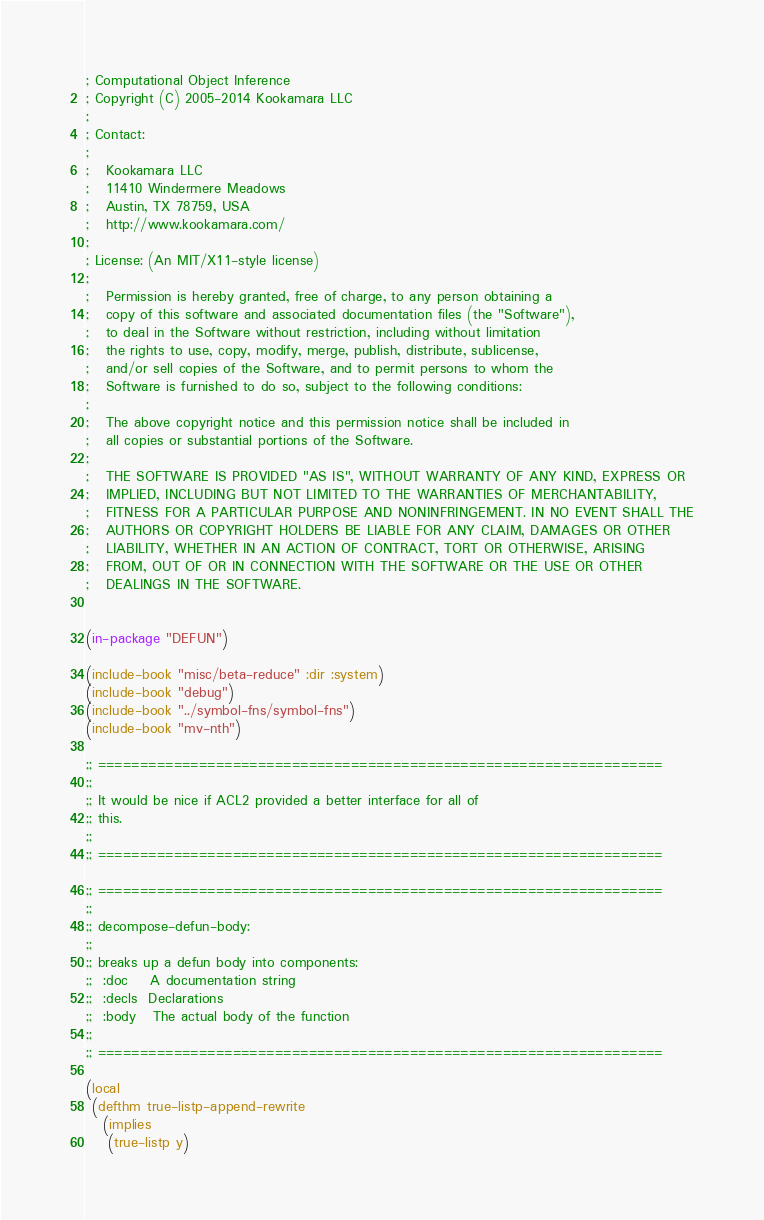Convert code to text. <code><loc_0><loc_0><loc_500><loc_500><_Lisp_>; Computational Object Inference
; Copyright (C) 2005-2014 Kookamara LLC
;
; Contact:
;
;   Kookamara LLC
;   11410 Windermere Meadows
;   Austin, TX 78759, USA
;   http://www.kookamara.com/
;
; License: (An MIT/X11-style license)
;
;   Permission is hereby granted, free of charge, to any person obtaining a
;   copy of this software and associated documentation files (the "Software"),
;   to deal in the Software without restriction, including without limitation
;   the rights to use, copy, modify, merge, publish, distribute, sublicense,
;   and/or sell copies of the Software, and to permit persons to whom the
;   Software is furnished to do so, subject to the following conditions:
;
;   The above copyright notice and this permission notice shall be included in
;   all copies or substantial portions of the Software.
;
;   THE SOFTWARE IS PROVIDED "AS IS", WITHOUT WARRANTY OF ANY KIND, EXPRESS OR
;   IMPLIED, INCLUDING BUT NOT LIMITED TO THE WARRANTIES OF MERCHANTABILITY,
;   FITNESS FOR A PARTICULAR PURPOSE AND NONINFRINGEMENT. IN NO EVENT SHALL THE
;   AUTHORS OR COPYRIGHT HOLDERS BE LIABLE FOR ANY CLAIM, DAMAGES OR OTHER
;   LIABILITY, WHETHER IN AN ACTION OF CONTRACT, TORT OR OTHERWISE, ARISING
;   FROM, OUT OF OR IN CONNECTION WITH THE SOFTWARE OR THE USE OR OTHER
;   DEALINGS IN THE SOFTWARE.


(in-package "DEFUN")

(include-book "misc/beta-reduce" :dir :system)
(include-book "debug")
(include-book "../symbol-fns/symbol-fns")
(include-book "mv-nth")

;; ===================================================================
;;
;; It would be nice if ACL2 provided a better interface for all of
;; this.
;;
;; ===================================================================

;; ===================================================================
;;
;; decompose-defun-body:
;;
;; breaks up a defun body into components:
;;  :doc    A documentation string
;;  :decls  Declarations
;;  :body   The actual body of the function
;;
;; ===================================================================

(local
 (defthm true-listp-append-rewrite
   (implies
    (true-listp y)</code> 